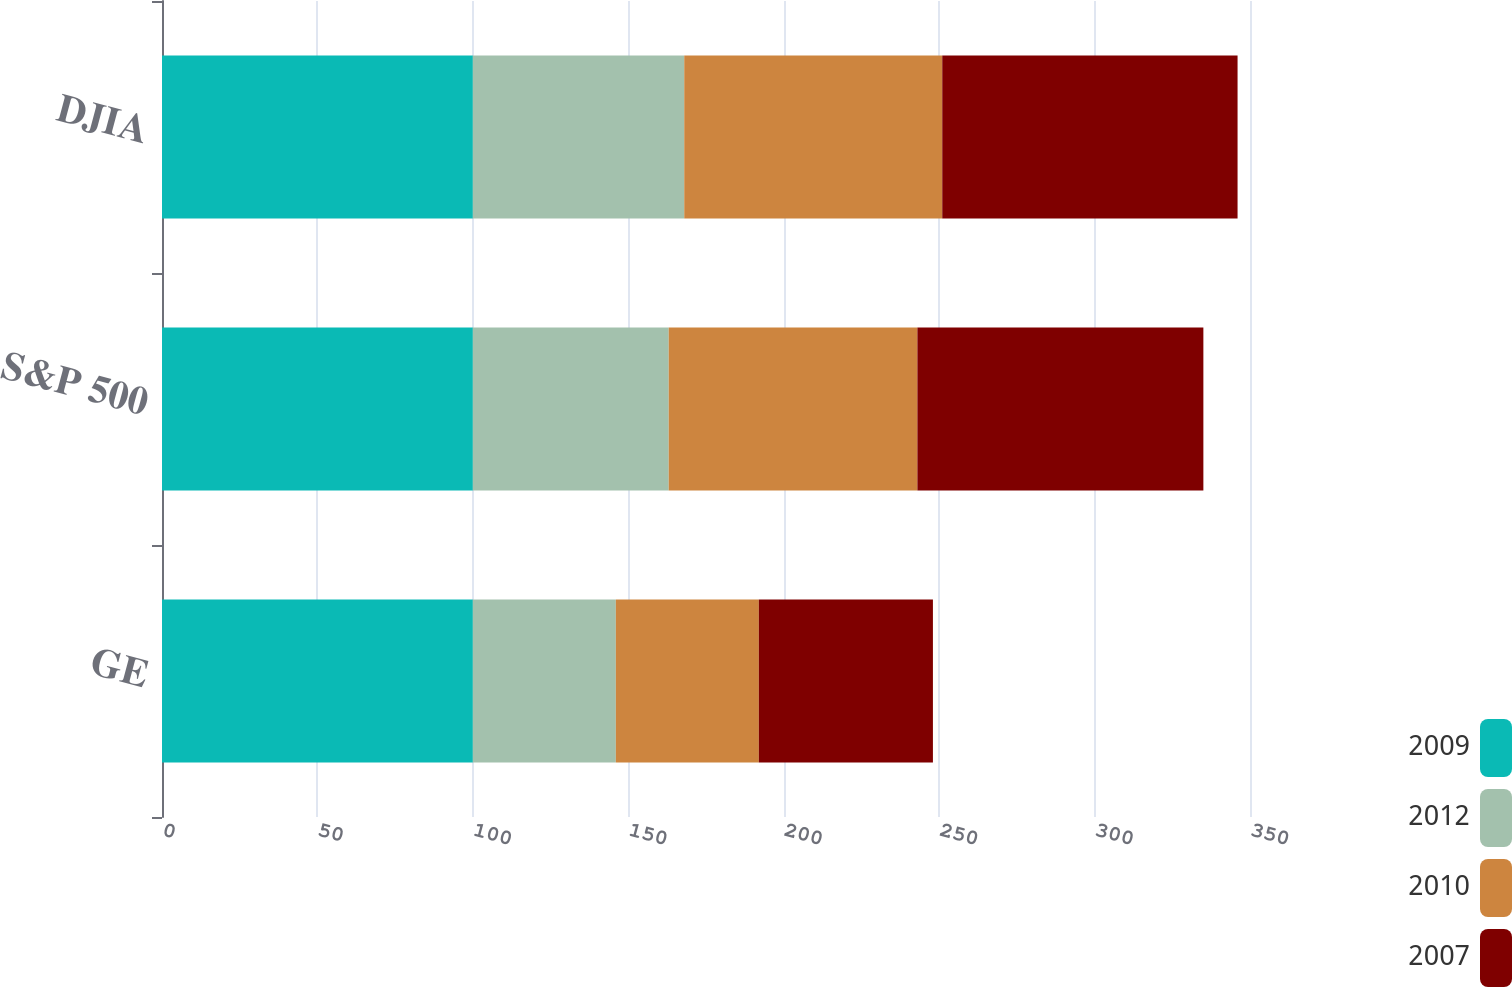<chart> <loc_0><loc_0><loc_500><loc_500><stacked_bar_chart><ecel><fcel>GE<fcel>S&P 500<fcel>DJIA<nl><fcel>2009<fcel>100<fcel>100<fcel>100<nl><fcel>2012<fcel>46<fcel>63<fcel>68<nl><fcel>2010<fcel>46<fcel>80<fcel>83<nl><fcel>2007<fcel>56<fcel>92<fcel>95<nl></chart> 